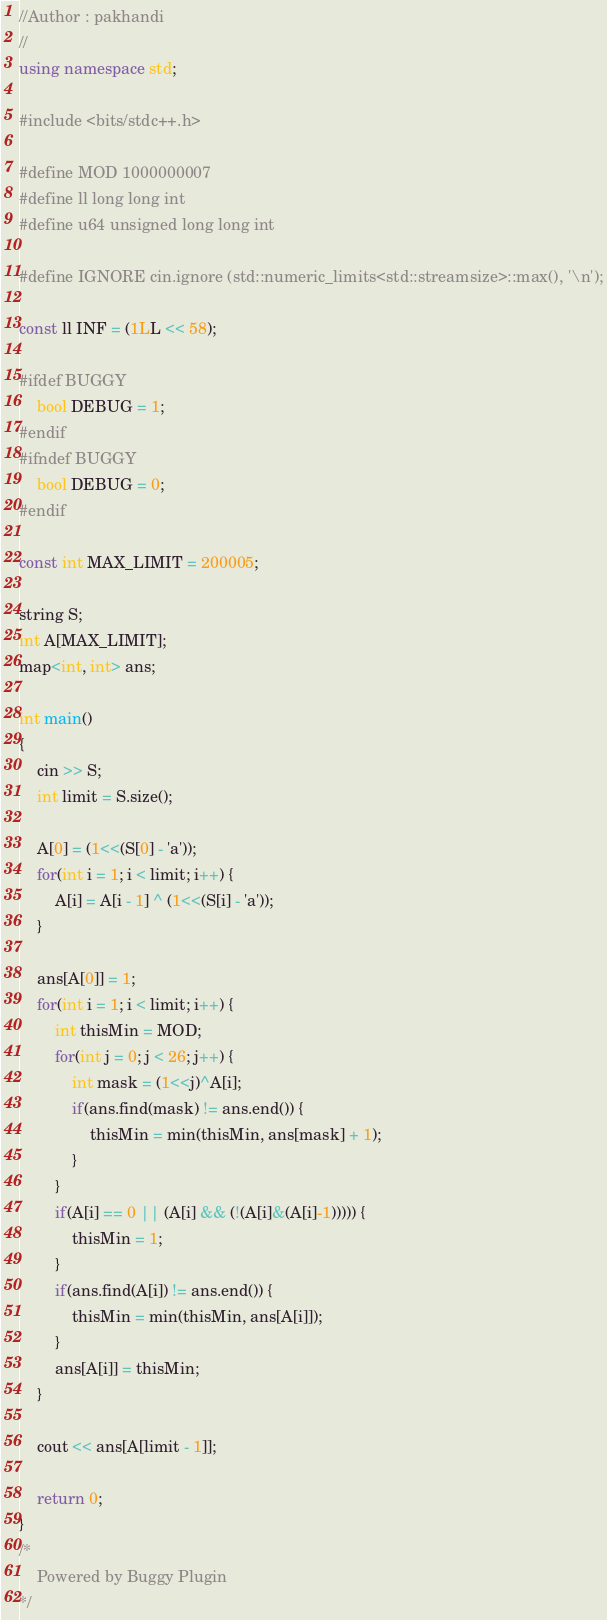Convert code to text. <code><loc_0><loc_0><loc_500><loc_500><_C++_>//Author : pakhandi
//
using namespace std;

#include <bits/stdc++.h>

#define MOD 1000000007
#define ll long long int
#define u64 unsigned long long int

#define IGNORE cin.ignore (std::numeric_limits<std::streamsize>::max(), '\n');

const ll INF = (1LL << 58);

#ifdef BUGGY
	bool DEBUG = 1;
#endif
#ifndef BUGGY
	bool DEBUG = 0;
#endif

const int MAX_LIMIT = 200005;

string S;
int A[MAX_LIMIT];
map<int, int> ans;

int main()
{
	cin >> S;
	int limit = S.size();

	A[0] = (1<<(S[0] - 'a'));
	for(int i = 1; i < limit; i++) {
		A[i] = A[i - 1] ^ (1<<(S[i] - 'a'));
	}

	ans[A[0]] = 1;
	for(int i = 1; i < limit; i++) {
		int thisMin = MOD;
		for(int j = 0; j < 26; j++) {
			int mask = (1<<j)^A[i];
			if(ans.find(mask) != ans.end()) {
				thisMin = min(thisMin, ans[mask] + 1);
			}
		}
		if(A[i] == 0 || (A[i] && (!(A[i]&(A[i]-1))))) {
			thisMin = 1;
		}
		if(ans.find(A[i]) != ans.end()) {
			thisMin = min(thisMin, ans[A[i]]);
		}
		ans[A[i]] = thisMin;
	}

	cout << ans[A[limit - 1]];

	return 0;
}
/*
	Powered by Buggy Plugin
*/</code> 